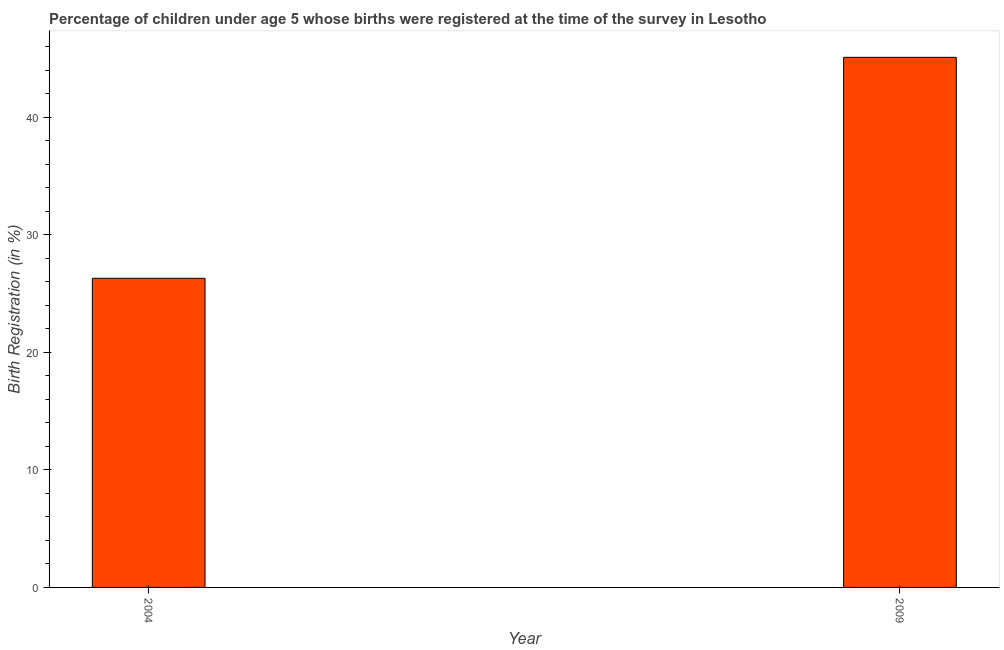Does the graph contain any zero values?
Your response must be concise. No. What is the title of the graph?
Your answer should be compact. Percentage of children under age 5 whose births were registered at the time of the survey in Lesotho. What is the label or title of the Y-axis?
Offer a very short reply. Birth Registration (in %). What is the birth registration in 2009?
Keep it short and to the point. 45.1. Across all years, what is the maximum birth registration?
Keep it short and to the point. 45.1. Across all years, what is the minimum birth registration?
Make the answer very short. 26.3. In which year was the birth registration maximum?
Your answer should be very brief. 2009. What is the sum of the birth registration?
Offer a very short reply. 71.4. What is the difference between the birth registration in 2004 and 2009?
Give a very brief answer. -18.8. What is the average birth registration per year?
Offer a very short reply. 35.7. What is the median birth registration?
Ensure brevity in your answer.  35.7. In how many years, is the birth registration greater than 34 %?
Provide a short and direct response. 1. Do a majority of the years between 2009 and 2004 (inclusive) have birth registration greater than 28 %?
Your answer should be very brief. No. What is the ratio of the birth registration in 2004 to that in 2009?
Offer a terse response. 0.58. In how many years, is the birth registration greater than the average birth registration taken over all years?
Provide a succinct answer. 1. Are all the bars in the graph horizontal?
Make the answer very short. No. What is the difference between two consecutive major ticks on the Y-axis?
Provide a short and direct response. 10. Are the values on the major ticks of Y-axis written in scientific E-notation?
Provide a succinct answer. No. What is the Birth Registration (in %) in 2004?
Provide a short and direct response. 26.3. What is the Birth Registration (in %) in 2009?
Make the answer very short. 45.1. What is the difference between the Birth Registration (in %) in 2004 and 2009?
Your answer should be very brief. -18.8. What is the ratio of the Birth Registration (in %) in 2004 to that in 2009?
Provide a short and direct response. 0.58. 